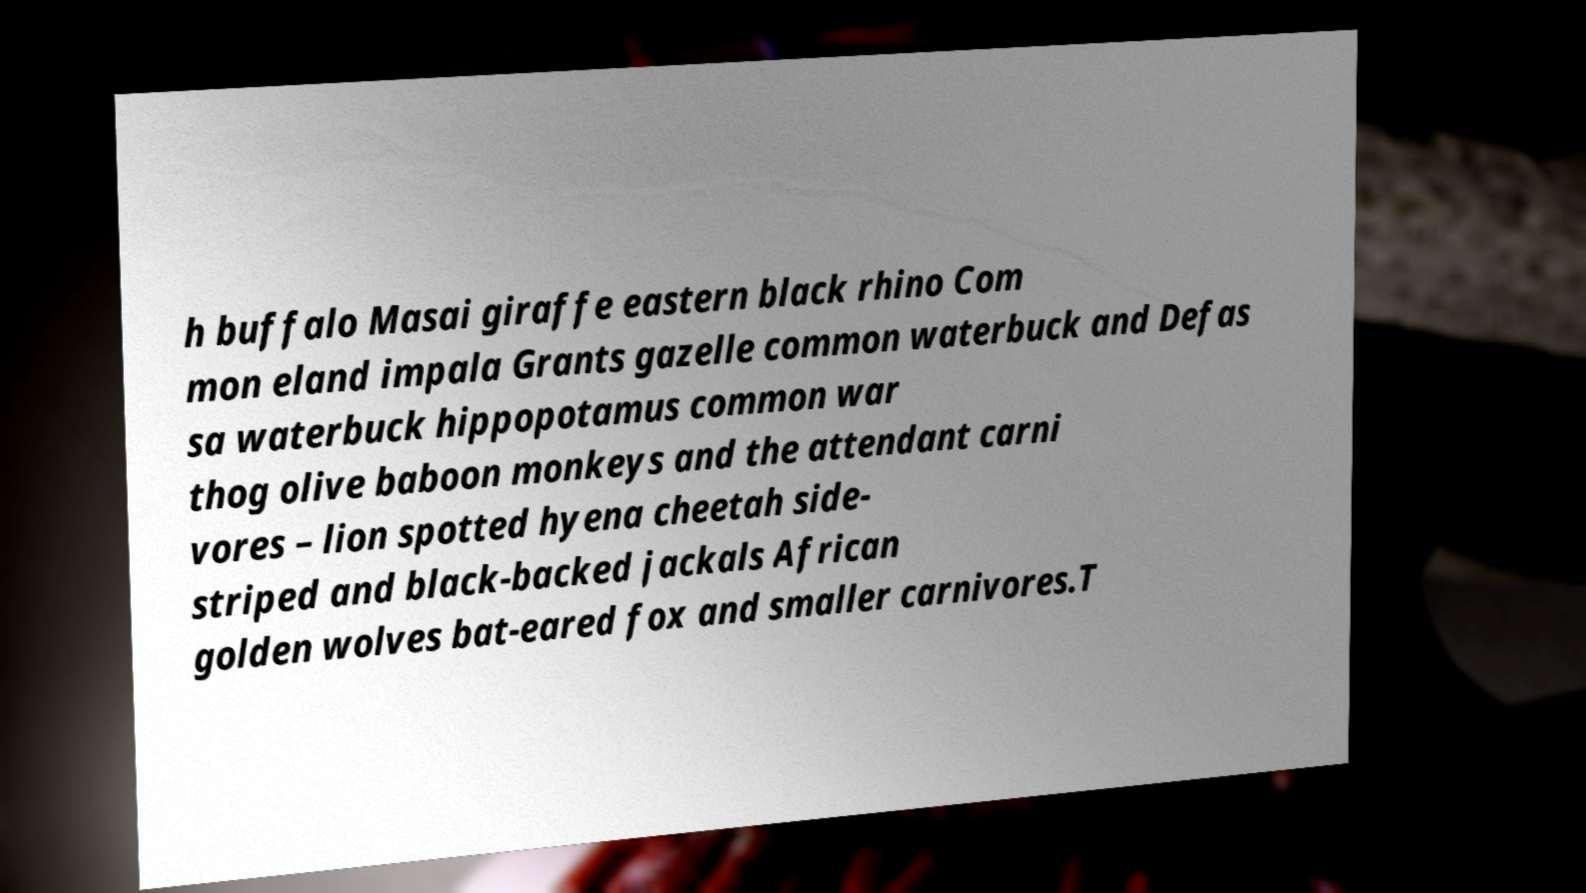I need the written content from this picture converted into text. Can you do that? h buffalo Masai giraffe eastern black rhino Com mon eland impala Grants gazelle common waterbuck and Defas sa waterbuck hippopotamus common war thog olive baboon monkeys and the attendant carni vores – lion spotted hyena cheetah side- striped and black-backed jackals African golden wolves bat-eared fox and smaller carnivores.T 